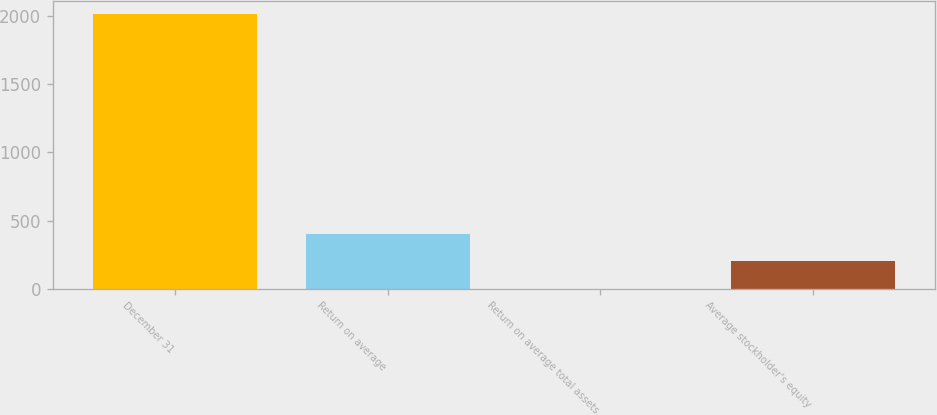Convert chart. <chart><loc_0><loc_0><loc_500><loc_500><bar_chart><fcel>December 31<fcel>Return on average<fcel>Return on average total assets<fcel>Average stockholder's equity<nl><fcel>2014<fcel>403.53<fcel>0.91<fcel>202.22<nl></chart> 